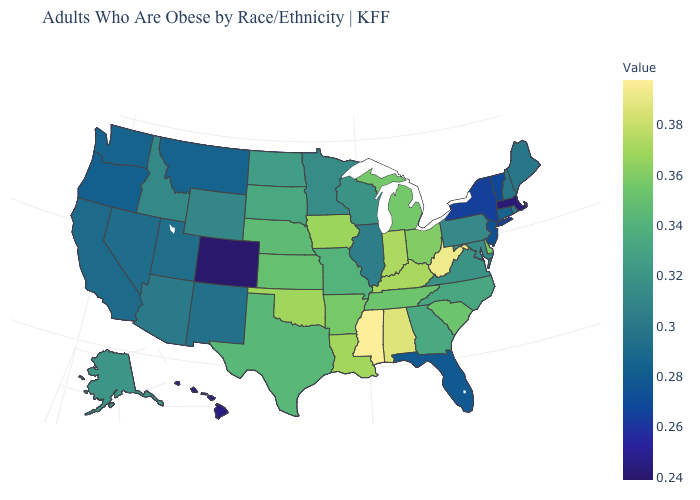Is the legend a continuous bar?
Be succinct. Yes. Does Illinois have the lowest value in the MidWest?
Answer briefly. Yes. Does Nevada have the highest value in the West?
Be succinct. No. 